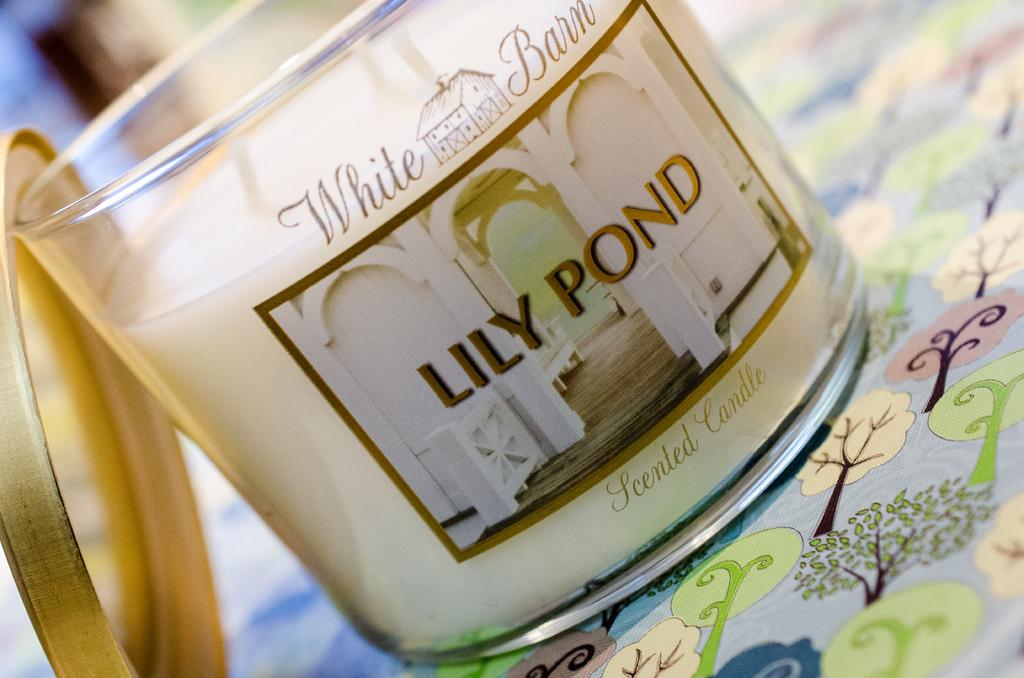<image>
Give a short and clear explanation of the subsequent image. a Lily Pond candle on a floral pattern table 